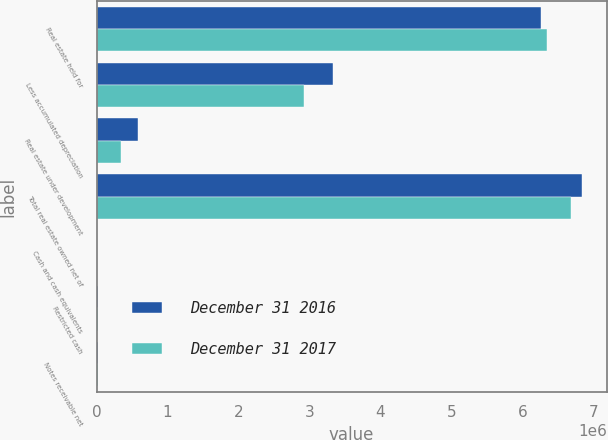<chart> <loc_0><loc_0><loc_500><loc_500><stacked_bar_chart><ecel><fcel>Real estate held for<fcel>Less accumulated depreciation<fcel>Real estate under development<fcel>Total real estate owned net of<fcel>Cash and cash equivalents<fcel>Restricted cash<fcel>Notes receivable net<nl><fcel>December 31 2016<fcel>6.2584e+06<fcel>3.32631e+06<fcel>588636<fcel>6.84704e+06<fcel>2038<fcel>19792<fcel>19469<nl><fcel>December 31 2017<fcel>6.34878e+06<fcel>2.92307e+06<fcel>342282<fcel>6.69213e+06<fcel>2112<fcel>19994<fcel>19790<nl></chart> 